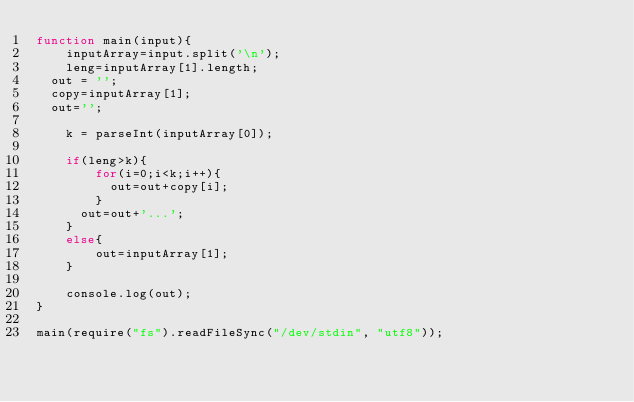Convert code to text. <code><loc_0><loc_0><loc_500><loc_500><_JavaScript_>function main(input){
    inputArray=input.split('\n');
    leng=inputArray[1].length;
  out = '';
  copy=inputArray[1];
  out='';

    k = parseInt(inputArray[0]);

    if(leng>k){
		for(i=0;i<k;i++){
          out=out+copy[i];
        }
      out=out+'...';
    }
    else{
        out=inputArray[1];
    }

    console.log(out);
}
 
main(require("fs").readFileSync("/dev/stdin", "utf8"));</code> 